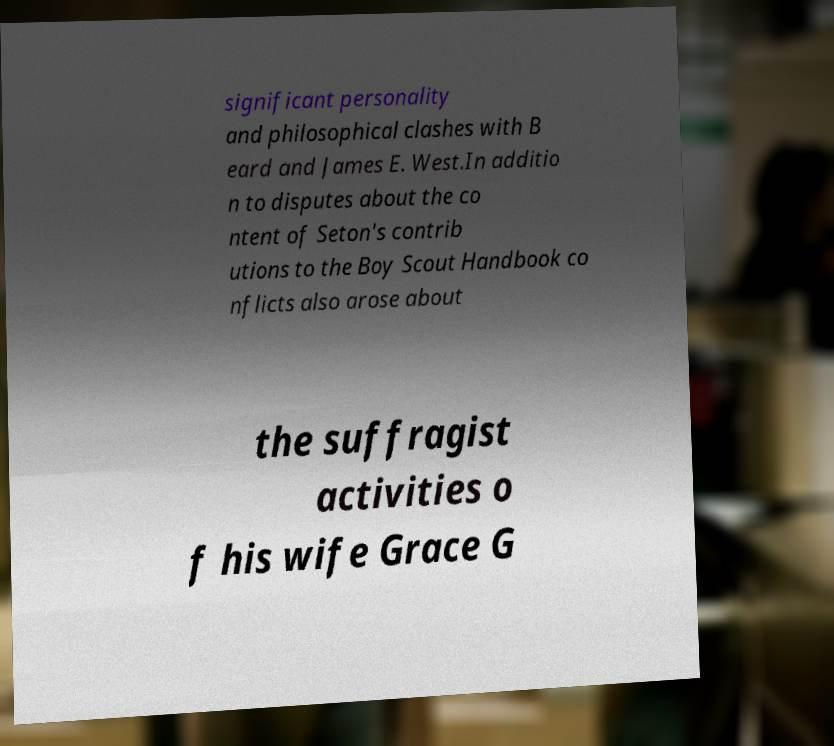Could you assist in decoding the text presented in this image and type it out clearly? significant personality and philosophical clashes with B eard and James E. West.In additio n to disputes about the co ntent of Seton's contrib utions to the Boy Scout Handbook co nflicts also arose about the suffragist activities o f his wife Grace G 